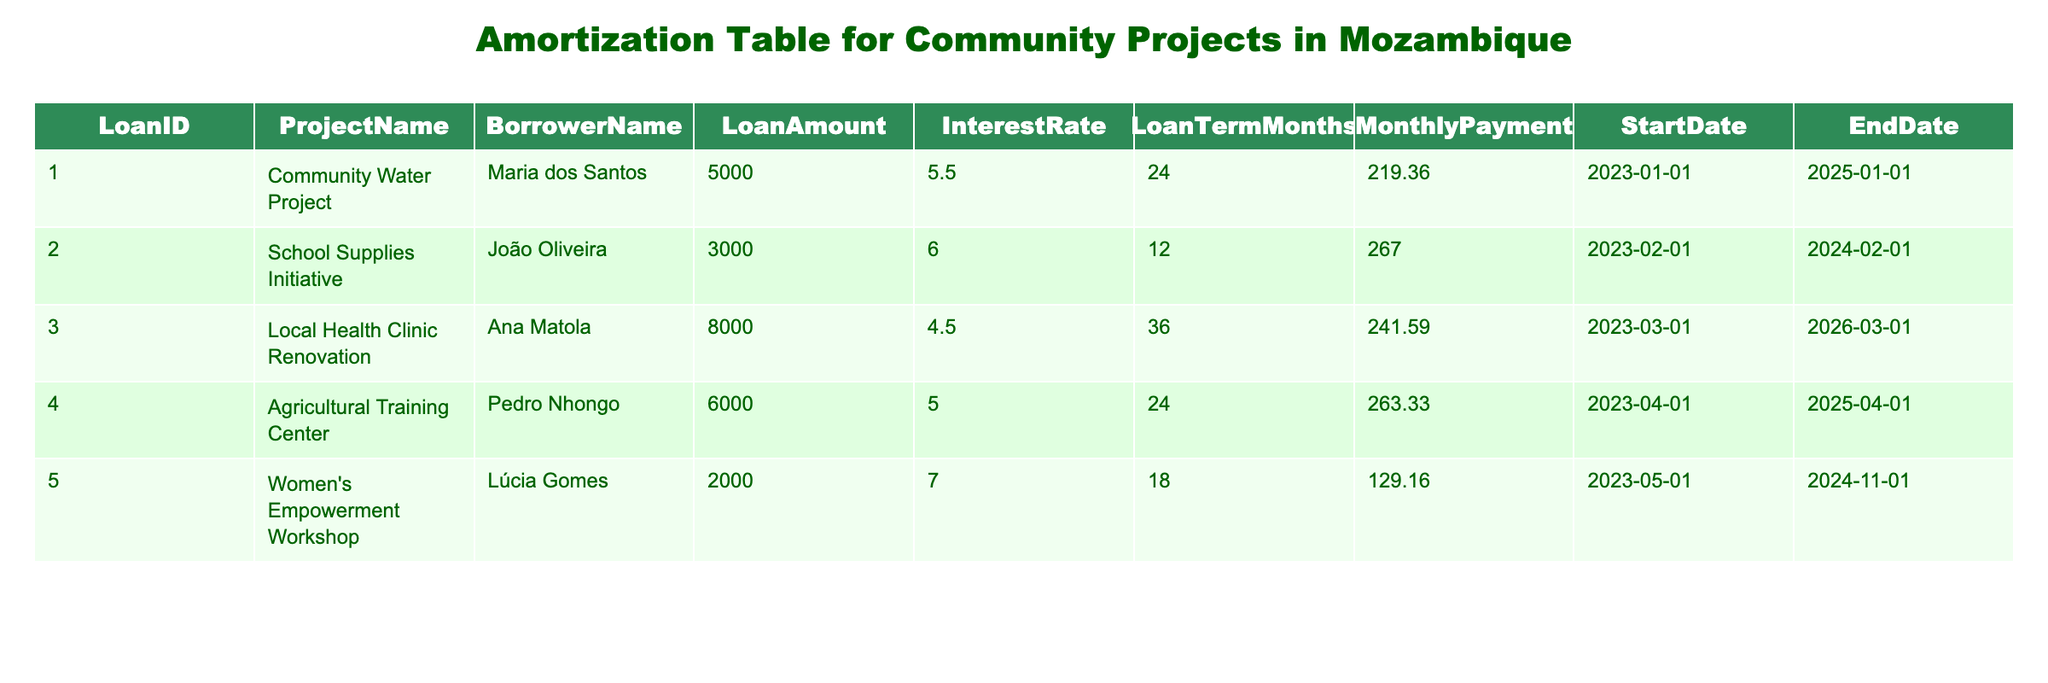What is the loan amount for the Women's Empowerment Workshop? The table shows that the loan amount for the Women's Empowerment Workshop is listed under the LoanAmount column for that specific project. It states 2000.
Answer: 2000 Which project has the highest interest rate? By comparing the InterestRate column across all projects, it's clear that the Women's Empowerment Workshop has the highest interest rate at 7.0.
Answer: Women's Empowerment Workshop What is the total loan amount for all projects? To find the total loan amount, we add up the LoanAmount for each project: 5000 + 3000 + 8000 + 6000 + 2000 = 24000.
Answer: 24000 How many months is the loan term for the Local Health Clinic Renovation? Looking at the LoanTermMonths column for the Local Health Clinic Renovation, it shows a term of 36 months.
Answer: 36 months Is the School Supplies Initiative loan ending sooner than the Agricultural Training Center loan? The end date for the School Supplies Initiative is 2024-02-01, while the Agricultural Training Center loan ends on 2025-04-01. Since 2024-02-01 is sooner than 2025-04-01, the statement is true.
Answer: Yes What is the average monthly payment for all the projects? To calculate the average monthly payment, we first sum the MonthlyPayment values: 219.36 + 267.00 + 241.59 + 263.33 + 129.16 = 1120.44. Then we divide by the number of projects, which is 5, giving us an average of 1120.44 / 5 = 224.09.
Answer: 224.09 Which borrower has a loan that ends last? By comparing the EndDate column for all borrowers, Ana Matola (for the Local Health Clinic Renovation) has the latest end date of 2026-03-01.
Answer: Ana Matola How much more is the loan amount for the Community Water Project compared to the Women's Empowerment Workshop? The difference in loan amounts between the Community Water Project (5000) and Women's Empowerment Workshop (2000) is calculated as follows: 5000 - 2000 = 3000.
Answer: 3000 What is the total monthly payment for all projects combined? To find the total monthly payment, we need to add the MonthlyPayment for each project: 219.36 + 267.00 + 241.59 + 263.33 + 129.16 = 1120.44, which gives a total monthly payment of 1120.44.
Answer: 1120.44 